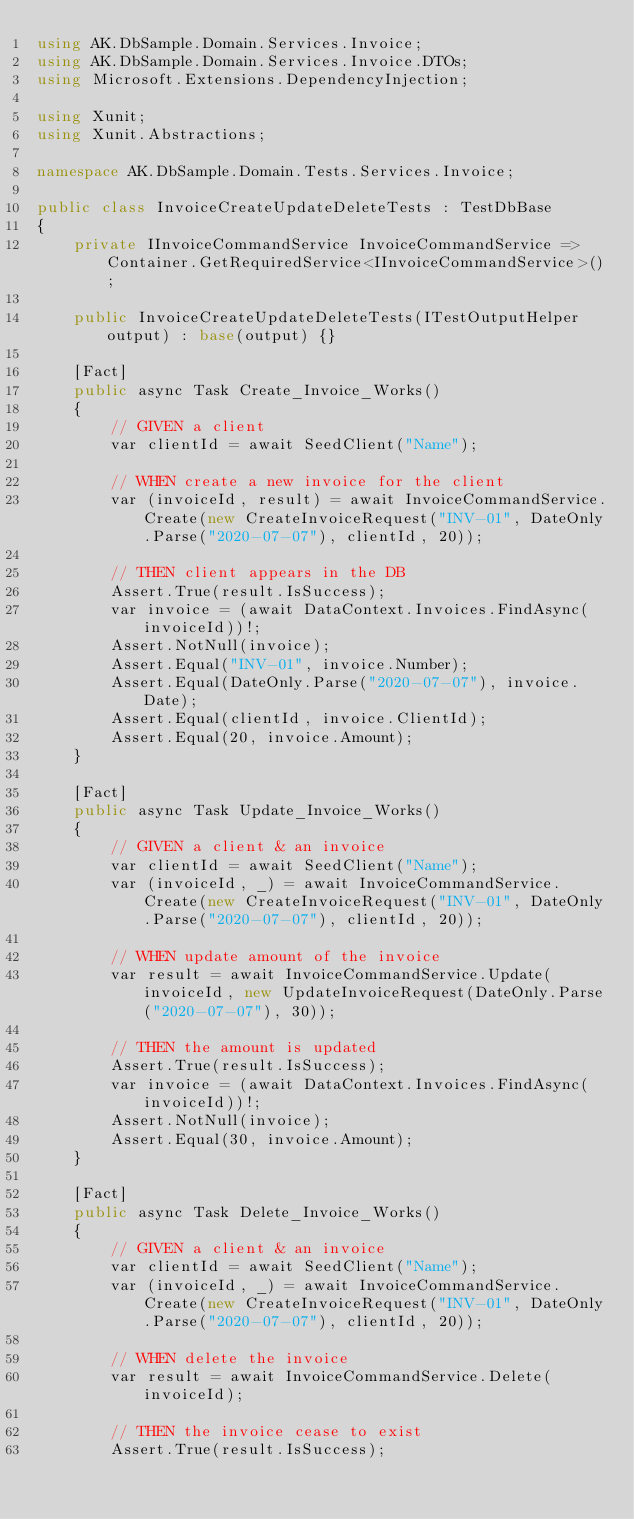<code> <loc_0><loc_0><loc_500><loc_500><_C#_>using AK.DbSample.Domain.Services.Invoice;
using AK.DbSample.Domain.Services.Invoice.DTOs;
using Microsoft.Extensions.DependencyInjection;

using Xunit;
using Xunit.Abstractions;

namespace AK.DbSample.Domain.Tests.Services.Invoice;

public class InvoiceCreateUpdateDeleteTests : TestDbBase
{
	private IInvoiceCommandService InvoiceCommandService => Container.GetRequiredService<IInvoiceCommandService>();

	public InvoiceCreateUpdateDeleteTests(ITestOutputHelper output) : base(output) {}
	
	[Fact]
	public async Task Create_Invoice_Works()
	{
		// GIVEN a client
		var clientId = await SeedClient("Name");
		
		// WHEN create a new invoice for the client
		var (invoiceId, result) = await InvoiceCommandService.Create(new CreateInvoiceRequest("INV-01", DateOnly.Parse("2020-07-07"), clientId, 20));
		
		// THEN client appears in the DB
		Assert.True(result.IsSuccess);
		var invoice = (await DataContext.Invoices.FindAsync(invoiceId))!;
		Assert.NotNull(invoice);
		Assert.Equal("INV-01", invoice.Number);
		Assert.Equal(DateOnly.Parse("2020-07-07"), invoice.Date);
		Assert.Equal(clientId, invoice.ClientId);
		Assert.Equal(20, invoice.Amount);
	}
	
	[Fact]
	public async Task Update_Invoice_Works()
	{
		// GIVEN a client & an invoice
		var clientId = await SeedClient("Name");
		var (invoiceId, _) = await InvoiceCommandService.Create(new CreateInvoiceRequest("INV-01", DateOnly.Parse("2020-07-07"), clientId, 20));
		
		// WHEN update amount of the invoice
		var result = await InvoiceCommandService.Update(invoiceId, new UpdateInvoiceRequest(DateOnly.Parse("2020-07-07"), 30));
		
		// THEN the amount is updated
		Assert.True(result.IsSuccess);
		var invoice = (await DataContext.Invoices.FindAsync(invoiceId))!;
		Assert.NotNull(invoice);
		Assert.Equal(30, invoice.Amount);
	}
	
	[Fact]
	public async Task Delete_Invoice_Works()
	{
		// GIVEN a client & an invoice
		var clientId = await SeedClient("Name");
		var (invoiceId, _) = await InvoiceCommandService.Create(new CreateInvoiceRequest("INV-01", DateOnly.Parse("2020-07-07"), clientId, 20));
		
		// WHEN delete the invoice
		var result = await InvoiceCommandService.Delete(invoiceId);
		
		// THEN the invoice cease to exist
		Assert.True(result.IsSuccess);</code> 